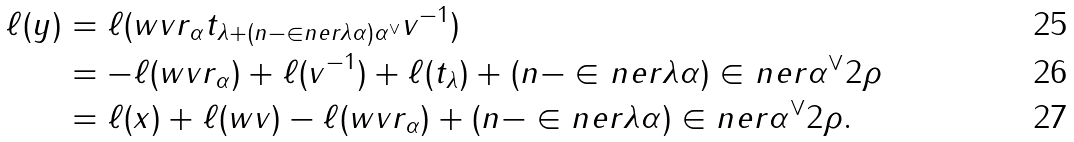Convert formula to latex. <formula><loc_0><loc_0><loc_500><loc_500>\ell ( y ) & = \ell ( w v r _ { \alpha } t _ { \lambda + ( n - \in n e r { \lambda } { \alpha } ) \alpha ^ { \vee } } v ^ { - 1 } ) \\ & = - \ell ( w v r _ { \alpha } ) + \ell ( v ^ { - 1 } ) + \ell ( t _ { \lambda } ) + ( n - \in n e r { \lambda } { \alpha } ) \in n e r { \alpha ^ { \vee } } { 2 \rho } \\ & = \ell ( x ) + \ell ( w v ) - \ell ( w v r _ { \alpha } ) + ( n - \in n e r { \lambda } { \alpha } ) \in n e r { \alpha ^ { \vee } } { 2 \rho } .</formula> 